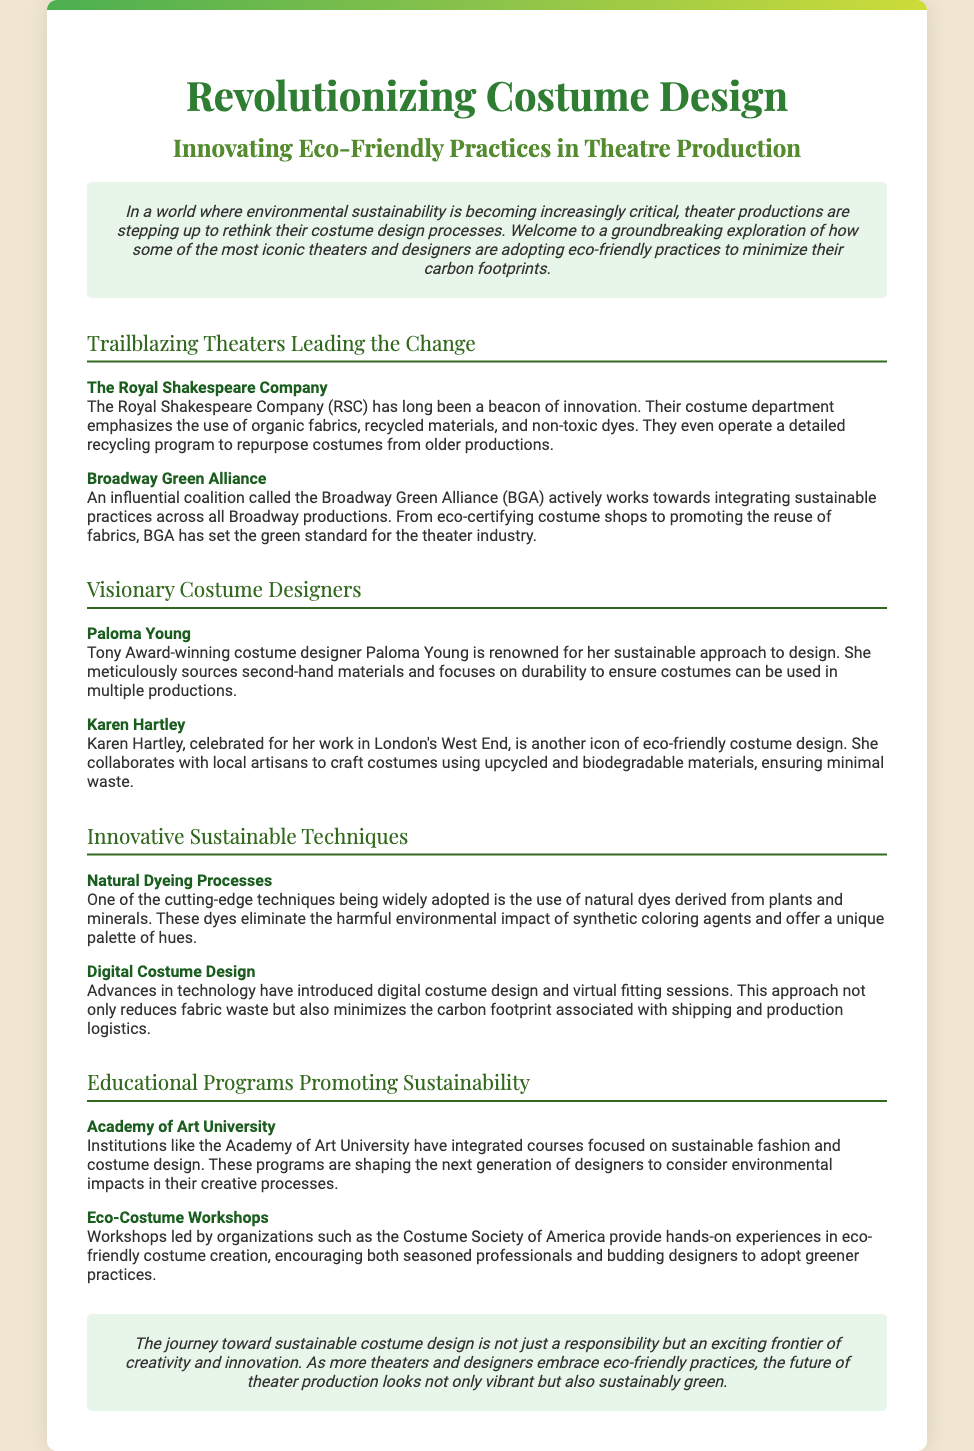What is the title of the Playbill? The title of the Playbill is found in the main heading, which presents the focus of the document.
Answer: Revolutionizing Costume Design Who is a visionary costume designer known for sustainable practices? The document names specific designers under the section for visionary costume designers and highlights their contributions.
Answer: Paloma Young What organization promotes eco-certifying costume shops? This information can be found in the section discussing organizations that are contributing to sustainable practices in theatre production.
Answer: Broadway Green Alliance What technique eliminates the impact of synthetic dyes? This technique is discussed under the section on innovative sustainable techniques and indicates an eco-friendly approach to coloring.
Answer: Natural Dyeing Processes Which university offers courses focused on sustainable costume design? The document mentions educational institutions promoting sustainability in costume design, specifying which ones are including such courses.
Answer: Academy of Art University What is one benefit of digital costume design mentioned in the document? The document outlines advantages derived from advances in technology, including reductions in specific areas that relate to production logistics.
Answer: Reduces fabric waste How does the Royal Shakespeare Company contribute to sustainability? The playbill describes specific practices adopted by the Royal Shakespeare Company regarding their costume design processes.
Answer: Organic fabrics and recycled materials What type of workshops does the Costume Society of America provide? This information is presented in the section discussing educational programs, indicating the focus of the workshops offered.
Answer: Eco-Costume Workshops 